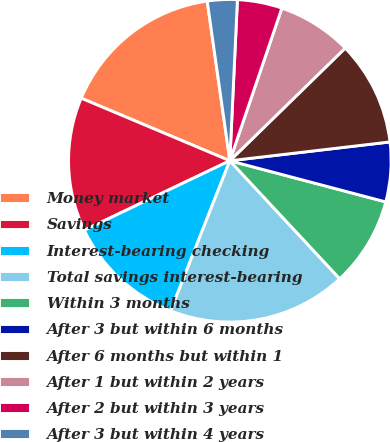Convert chart to OTSL. <chart><loc_0><loc_0><loc_500><loc_500><pie_chart><fcel>Money market<fcel>Savings<fcel>Interest-bearing checking<fcel>Total savings interest-bearing<fcel>Within 3 months<fcel>After 3 but within 6 months<fcel>After 6 months but within 1<fcel>After 1 but within 2 years<fcel>After 2 but within 3 years<fcel>After 3 but within 4 years<nl><fcel>16.42%<fcel>13.43%<fcel>11.94%<fcel>17.91%<fcel>8.96%<fcel>5.97%<fcel>10.45%<fcel>7.46%<fcel>4.48%<fcel>2.99%<nl></chart> 